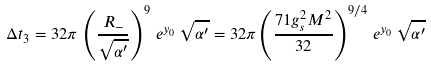Convert formula to latex. <formula><loc_0><loc_0><loc_500><loc_500>\Delta t _ { 3 } = 3 2 \pi \, \left ( \frac { R _ { - } } { \sqrt { \alpha ^ { \prime } } } \right ) ^ { 9 } \, e ^ { y _ { 0 } } \, \sqrt { \alpha ^ { \prime } } = 3 2 \pi \left ( \frac { 7 1 g _ { s } ^ { 2 } M ^ { 2 } } { 3 2 } \right ) ^ { 9 / 4 } \, e ^ { y _ { 0 } } \, \sqrt { \alpha ^ { \prime } }</formula> 